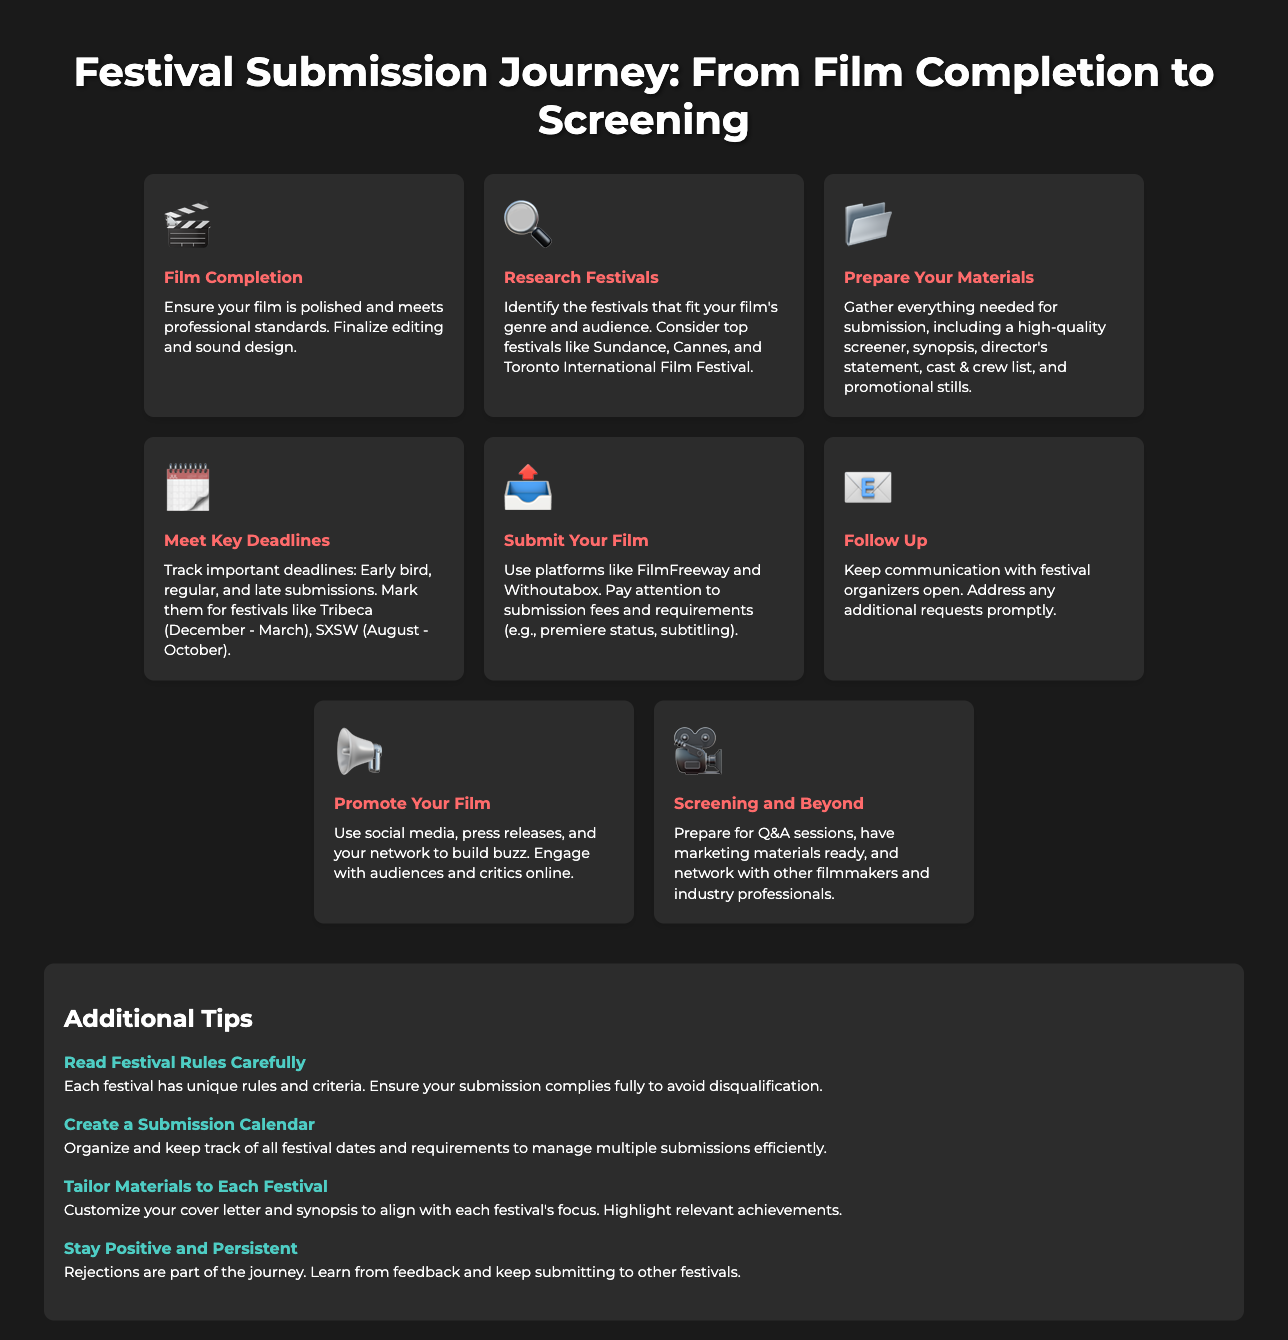What is the first step in the festival submission journey? The first step is to ensure your film is polished and meets professional standards, which is described as Film Completion in the infographic.
Answer: Film Completion Which festivals are mentioned as top festivals to research? The festivals mentioned include Sundance, Cannes, and Toronto International Film Festival as fitting for specific genres and audiences.
Answer: Sundance, Cannes, Toronto International Film Festival What is required to submit your film? Submitting your film requires a high-quality screener, synopsis, director's statement, cast & crew list, and promotional stills, as outlined in the Prepare Your Materials step.
Answer: High-quality screener, synopsis, director's statement, cast & crew list, promotional stills What action should be taken after submitting your film? After submitting your film, it's important to keep communication with festival organizers open, addressed in the Follow Up step.
Answer: Follow Up What should filmmakers do to promote their film? Filmmakers should use social media and press releases to build buzz and engage with audiences, as detailed in the Promote Your Film step.
Answer: Use social media, press releases What does "Meet Key Deadlines" involve? It involves tracking important deadlines for early bird, regular, and late submissions for specific festivals.
Answer: Tracking important deadlines How many additional tips are provided? The infographic includes a section titled Additional Tips that contains four tips for successful applications.
Answer: Four What should filmmakers do when they face rejections? The document advises filmmakers to learn from feedback and keep submitting to other festivals, which is part of the Stay Positive and Persistent tip.
Answer: Learn from feedback What is suggested for organizing festival submission dates? The infographic suggests creating a submission calendar to organize and keep track of all festival dates and requirements.
Answer: Create a submission calendar 